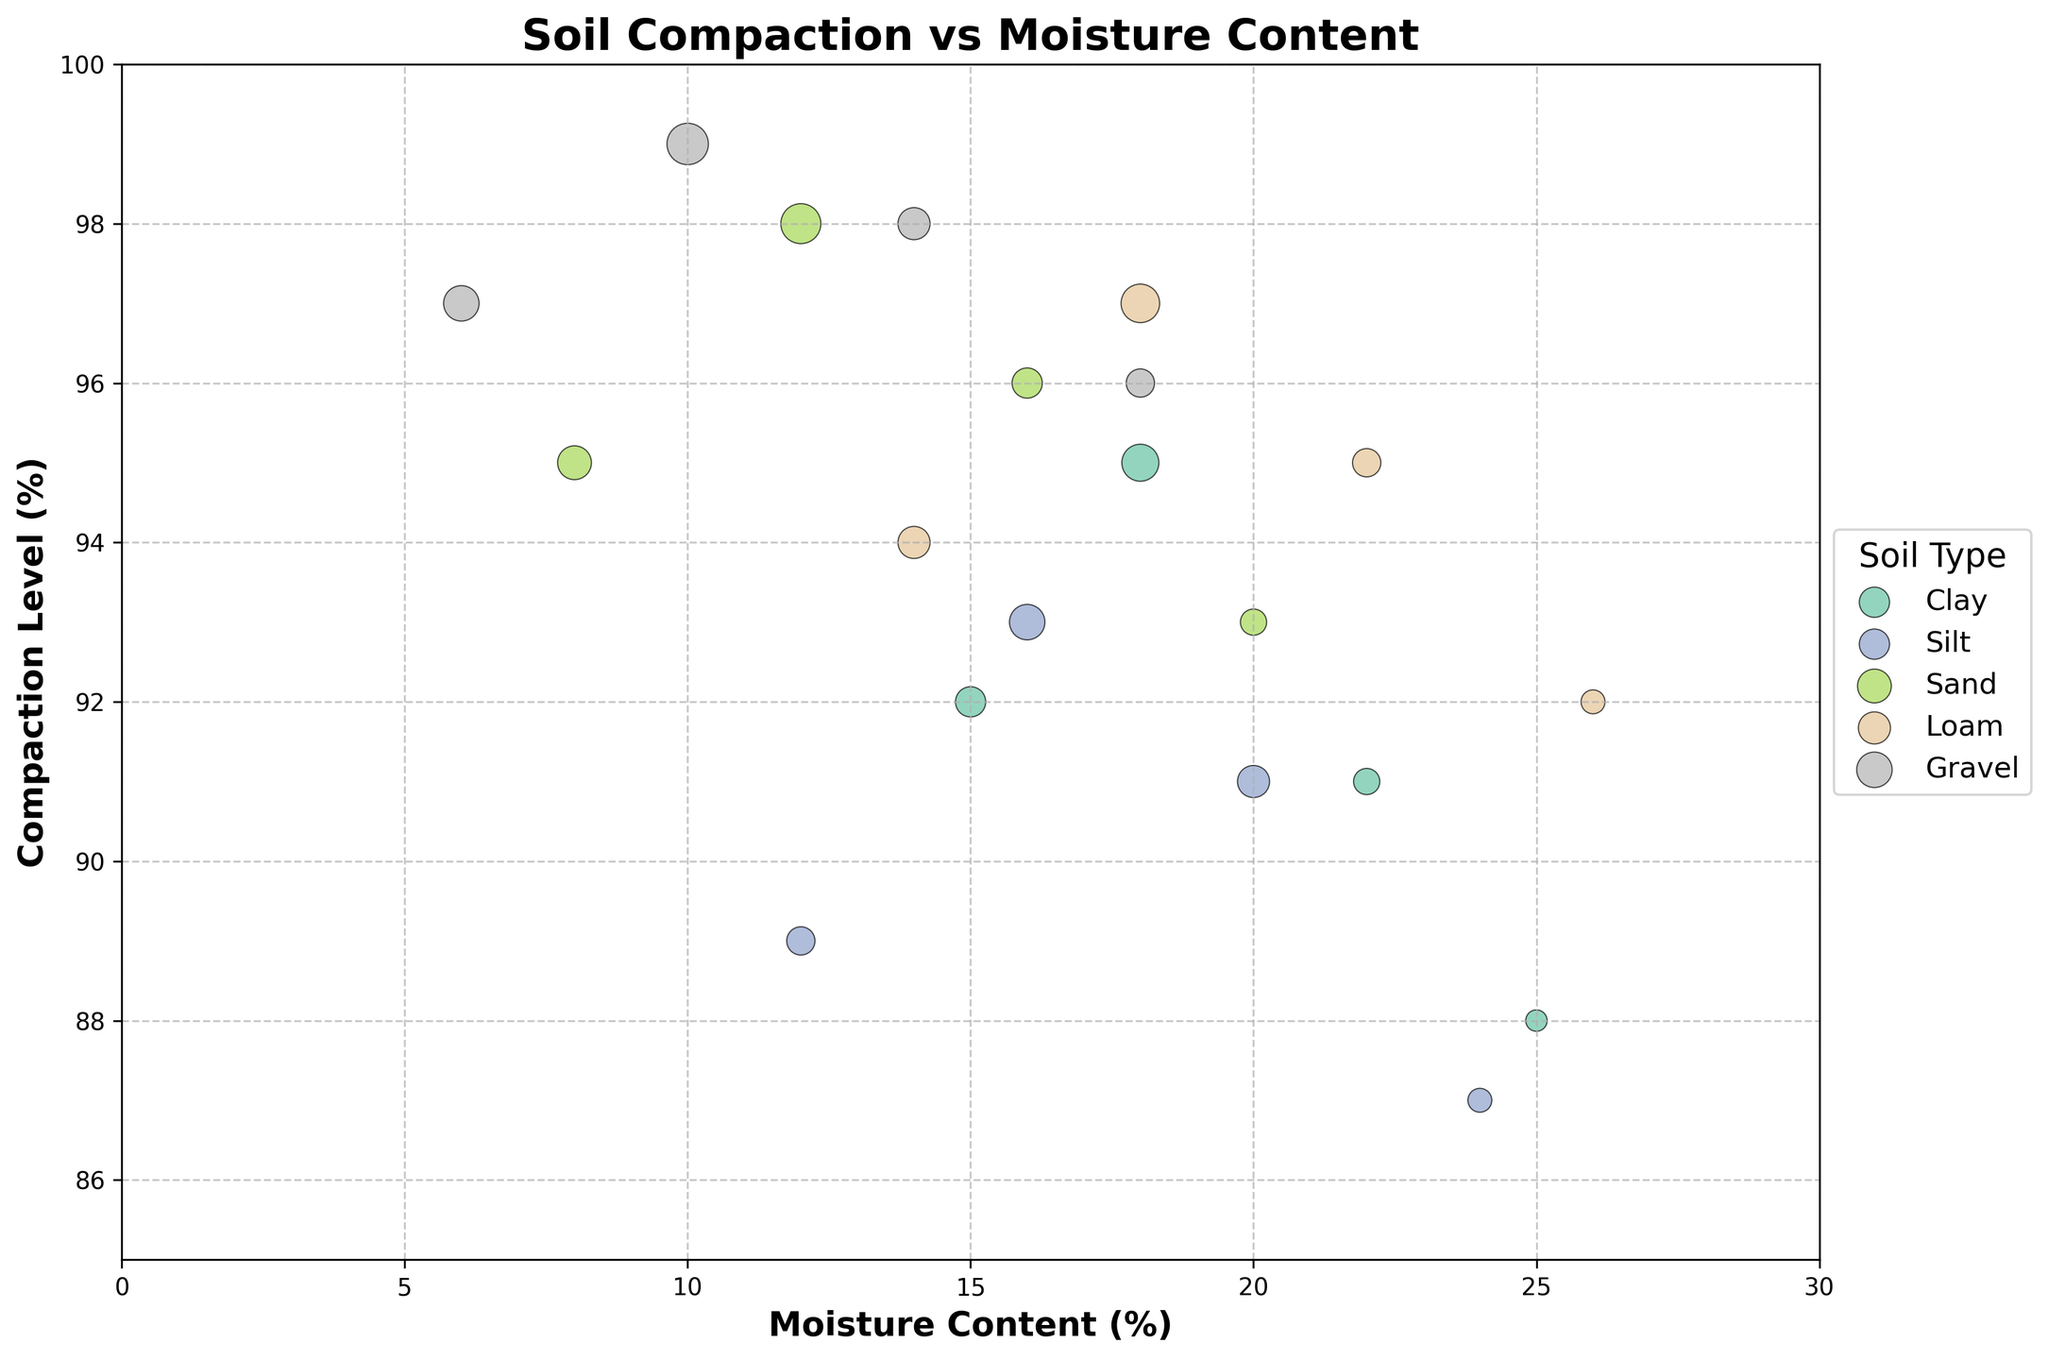What title does the figure have? The title is usually located at the top-center of the figure. In this case, it reads "Soil Compaction vs Moisture Content".
Answer: Soil Compaction vs Moisture Content What do the x-axis and y-axis represent? The labels on the axes of the figure indicate what they represent. The x-axis is labeled "Moisture Content (%)" and the y-axis is labeled "Compaction Level (%)".
Answer: Moisture Content (%) and Compaction Level (%) How many soil types are displayed in the figure? The legend on the right side of the figure lists all the different soil types represented in the scatterplot. They are Clay, Silt, Sand, Loam, and Gravel.
Answer: 5 Which soil type has the highest frequency at a specific point? By examining the size of the scatter plot points, the largest point indicates the highest frequency. The largest point corresponds to Gravel with a moisture content of 10% and a compaction level of 99%, which has a frequency of 15.
Answer: Gravel Which soil type shows the widest range of moisture content in the figure? By looking at the x-axis values for each soil type, Gravel appears to have a wide range from 6% to 18%. Comparatively, other soil types have smaller ranges.
Answer: Gravel What is the highest compaction level observed, and which soil type does it belong to? By inspecting the y-axis values and identifying the highest point on the scatterplot, the highest compaction level is 99%, which belongs to Gravel.
Answer: 99%, Gravel What is the average moisture content for the Clay soil type based on the figure? For Clay soil type, the moisture content values are 15%, 18%, 22%, and 25%. To find the average, sum these values and divide by the number of data points: (15 + 18 + 22 + 25)/4 = 20%.
Answer: 20% Which soil type has the most evenly distributed points across the compaction level and moisture content? By visually scanning the scatterplot, Loam’s points are more evenly distributed compared to other soil types which have more variability in either compaction or moisture content.
Answer: Loam Does any soil type show a general trend where higher moisture content corresponds to lower compaction levels? By observing general trends in the scatterplot, both Clay and Silt soil types show a tendency for higher moisture content to correspond with lower compaction levels.
Answer: Clay and Silt Is there any soil type that consistently appears to have a compaction level above 95% across points on the scatterplot? By checking the y-axis values, Sand consistently has points that have compaction levels above 95%.
Answer: Sand 